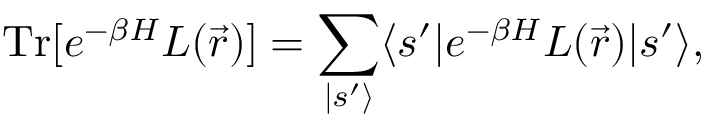Convert formula to latex. <formula><loc_0><loc_0><loc_500><loc_500>T r [ e ^ { - \beta H } L ( \vec { r } ) ] = \sum _ { | s ^ { \prime } \rangle } \langle s ^ { \prime } | e ^ { - \beta H } L ( \vec { r } ) | s ^ { \prime } \rangle ,</formula> 